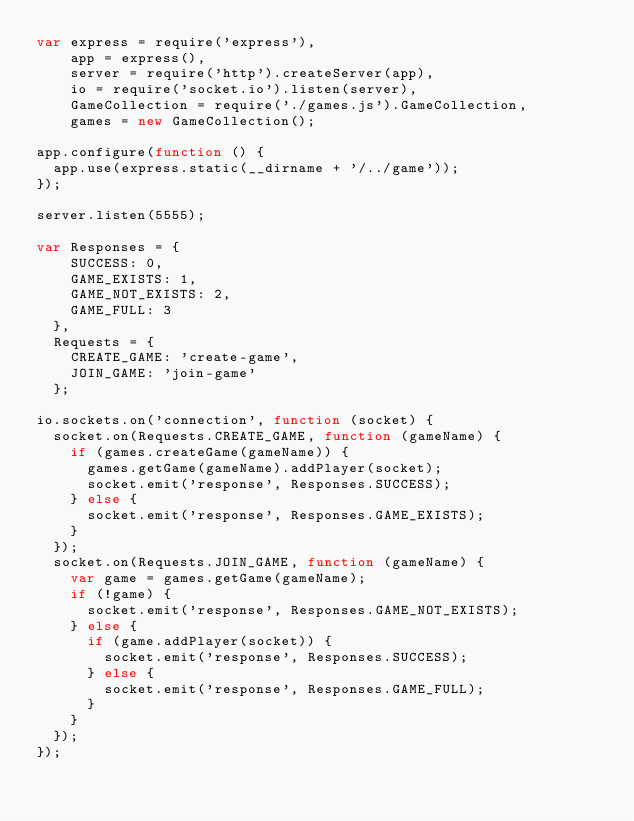<code> <loc_0><loc_0><loc_500><loc_500><_JavaScript_>var express = require('express'),
    app = express(),
    server = require('http').createServer(app),
    io = require('socket.io').listen(server),
    GameCollection = require('./games.js').GameCollection,
    games = new GameCollection();

app.configure(function () {
  app.use(express.static(__dirname + '/../game'));
});

server.listen(5555);

var Responses = {
    SUCCESS: 0,
    GAME_EXISTS: 1,
    GAME_NOT_EXISTS: 2,
    GAME_FULL: 3
  },
  Requests = {
    CREATE_GAME: 'create-game',
    JOIN_GAME: 'join-game'
  };

io.sockets.on('connection', function (socket) {
  socket.on(Requests.CREATE_GAME, function (gameName) {
    if (games.createGame(gameName)) {
      games.getGame(gameName).addPlayer(socket);
      socket.emit('response', Responses.SUCCESS);
    } else {
      socket.emit('response', Responses.GAME_EXISTS);
    }
  });
  socket.on(Requests.JOIN_GAME, function (gameName) {
    var game = games.getGame(gameName);
    if (!game) {
      socket.emit('response', Responses.GAME_NOT_EXISTS);
    } else {
      if (game.addPlayer(socket)) {
        socket.emit('response', Responses.SUCCESS);
      } else {
        socket.emit('response', Responses.GAME_FULL);
      }
    }
  });
});
</code> 